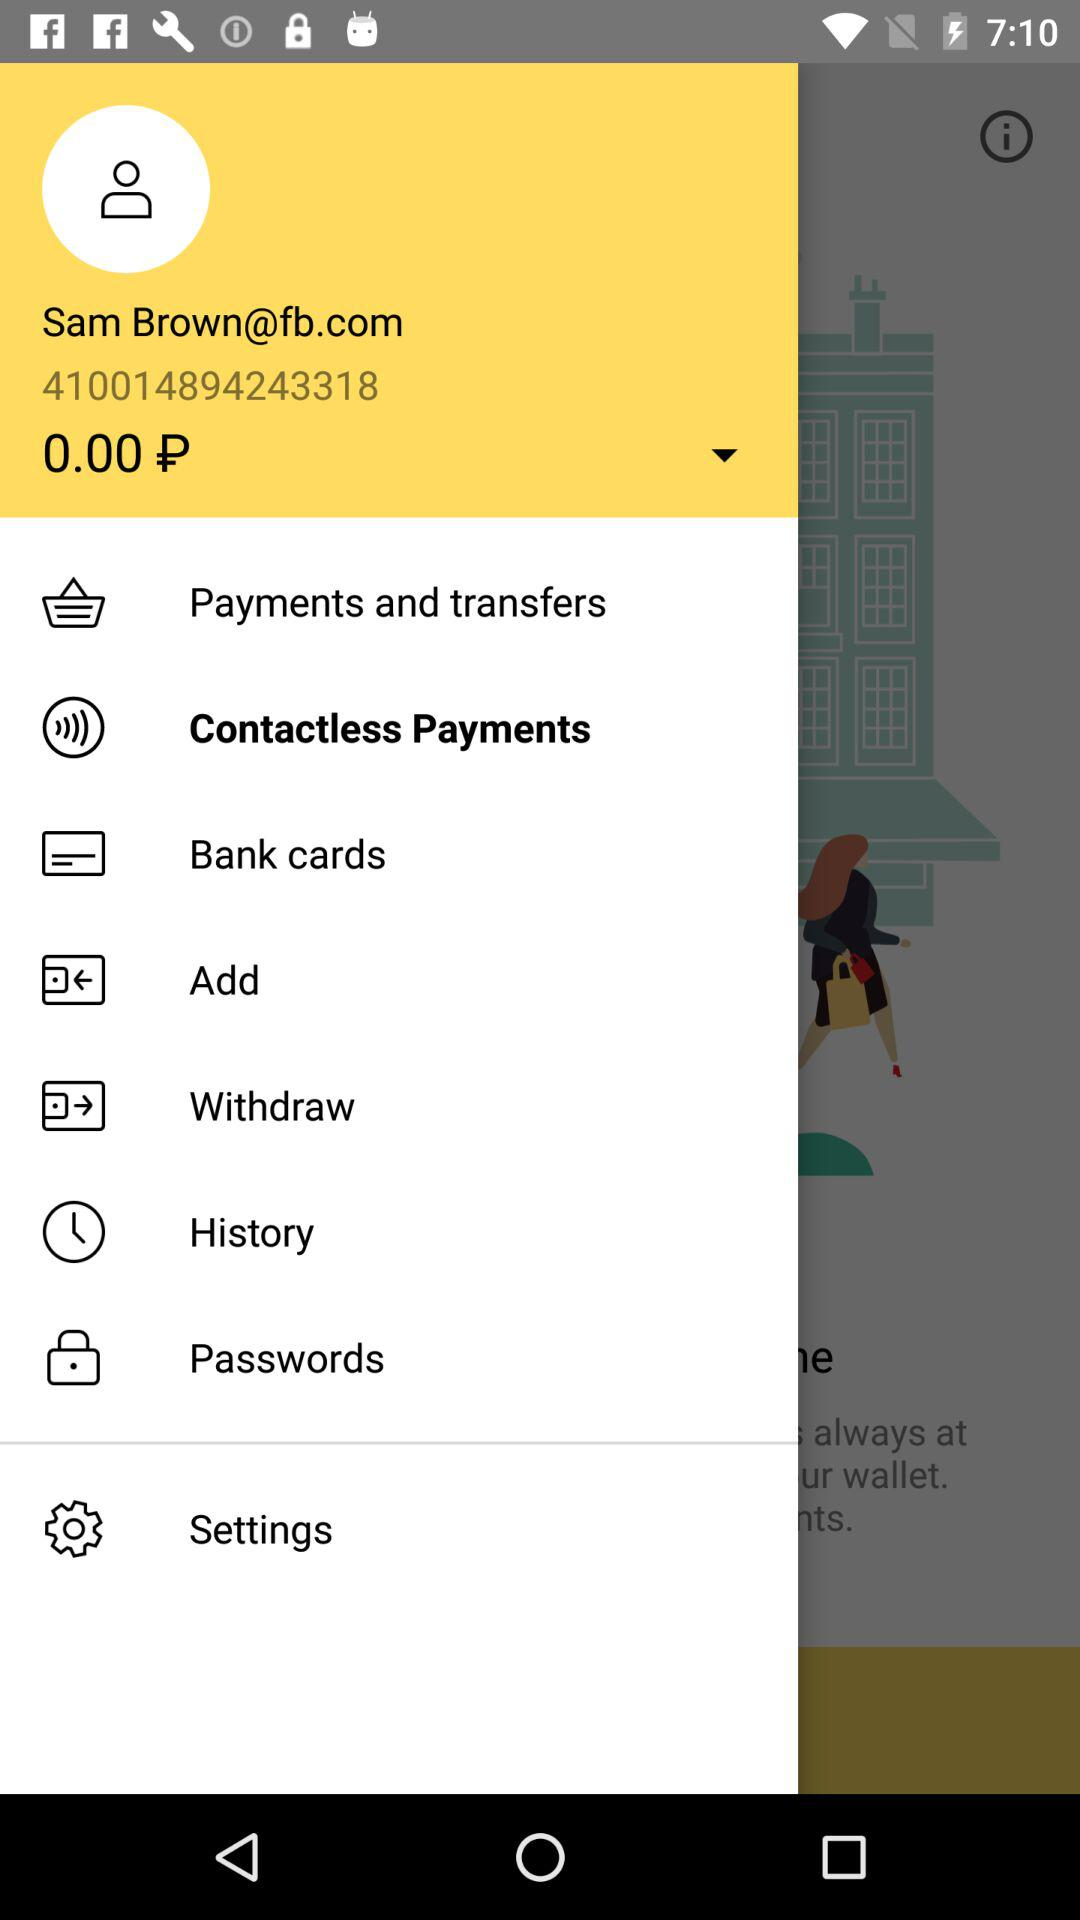How much money is in my account?
Answer the question using a single word or phrase. 0.00 P 